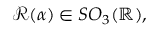<formula> <loc_0><loc_0><loc_500><loc_500>\mathcal { R } ( \alpha ) \in S O _ { 3 } ( \mathbb { R } ) ,</formula> 